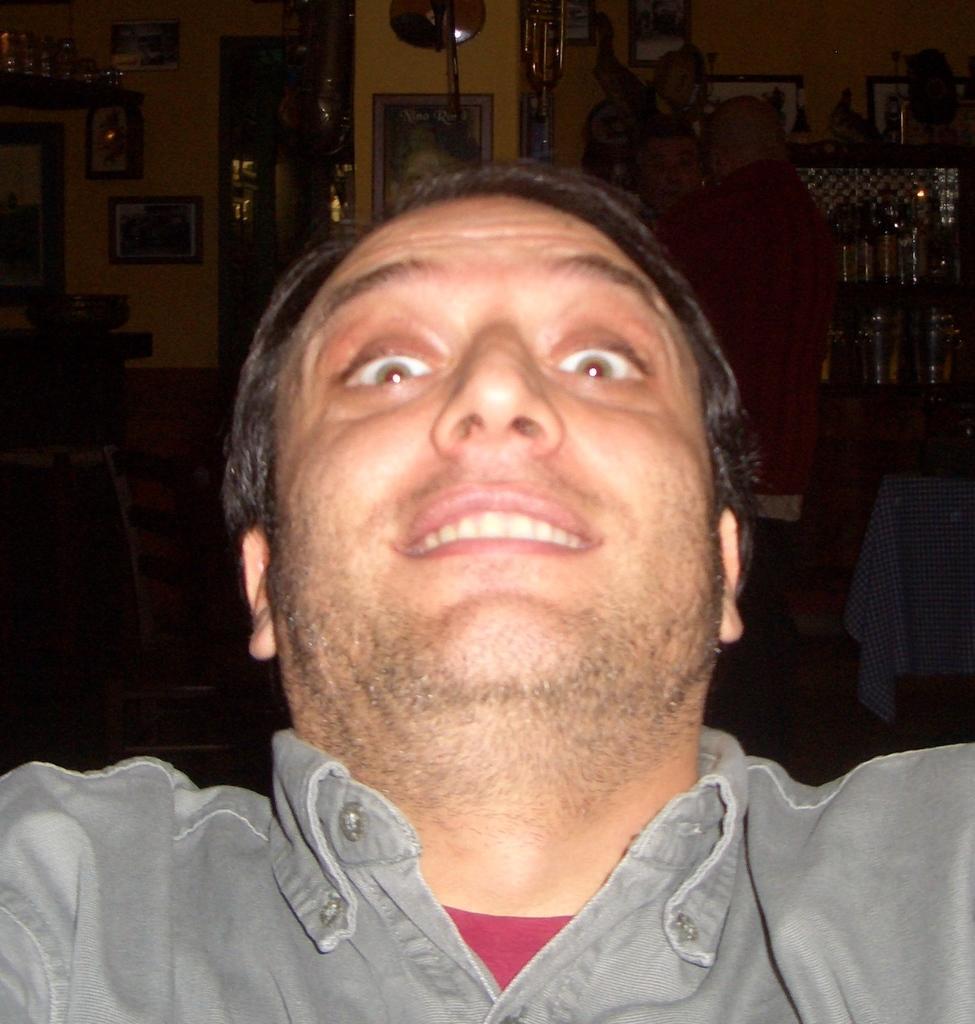Could you give a brief overview of what you see in this image? In this image I can see a man is smiling. The man is wearing grey color shirt. In the background I can see photos attached to the wall. The background of the image is dark. 